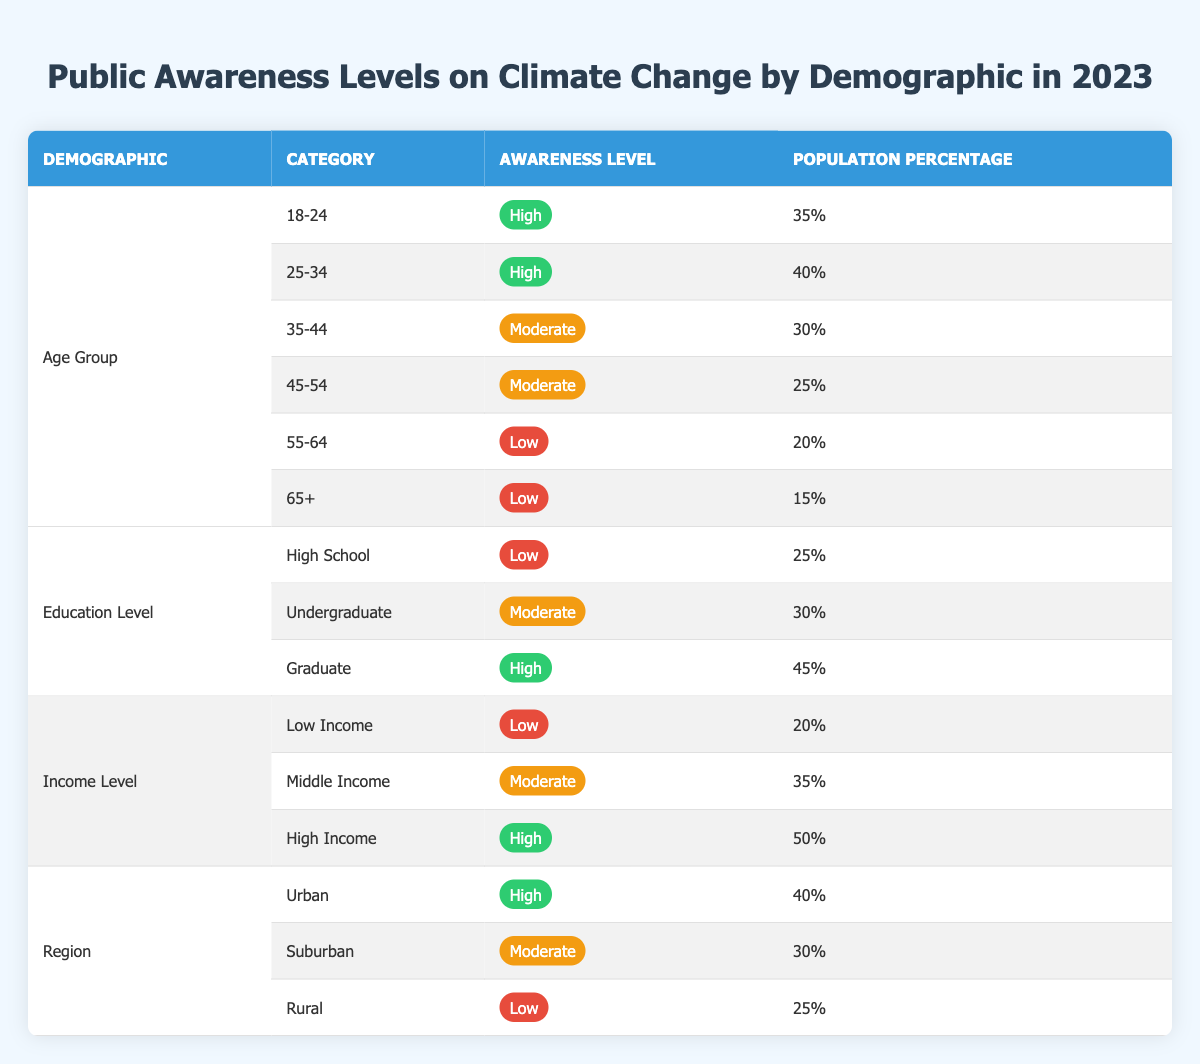What is the awareness level of the age group 55-64? The table indicates that for the age group 55-64, the awareness level is categorized as low.
Answer: Low Which income level has the highest population percentage? According to the table, the income level High Income has the highest population percentage of 50%.
Answer: High Income How many demographic categories are represented in the table? The table includes four demographic categories: Age Group, Education Level, Income Level, and Region.
Answer: Four What is the average population percentage for the awareness level classified as moderate? To find the average, we sum the percentages of the moderate awareness level across different demographics: 30% (35-44 Age Group) + 25% (45-54 Age Group) + 30% (Undergraduate Education Level) + 35% (Middle Income) + 30% (Suburban Region) = 150%. There are 5 occurrences, so the average is 150% / 5 = 30%.
Answer: 30% Is the awareness level in urban regions higher than in rural regions? The table shows that urban regions have an awareness level categorized as high (40%), while rural regions have a low awareness level (25%). Therefore, yes, urban awareness is higher.
Answer: Yes What percentage of the population in the 25-34 age group is considered high awareness? The table shows that 40% of the population in the 25-34 age group is categorized as having high awareness.
Answer: 40% Which education level has the lowest awareness level and what is its population percentage? The education level with the lowest awareness is High School, which has a population percentage of 25%.
Answer: High School, 25% How does the awareness level of low-income individuals compare to that of the 65+ age group? The low-income group has a low awareness level at 20%, while the 65+ age group has an even lower awareness level of 15%. Therefore, the awareness level of low-income individuals is higher than that of the 65+ age group.
Answer: Higher What is the difference in population percentage between the high awareness level in high-income individuals and the moderate awareness level in the suburban region? The high awareness level for high-income individuals is 50%, while the moderate awareness level in suburban regions is 30%. The difference is 50% - 30% = 20%.
Answer: 20% 